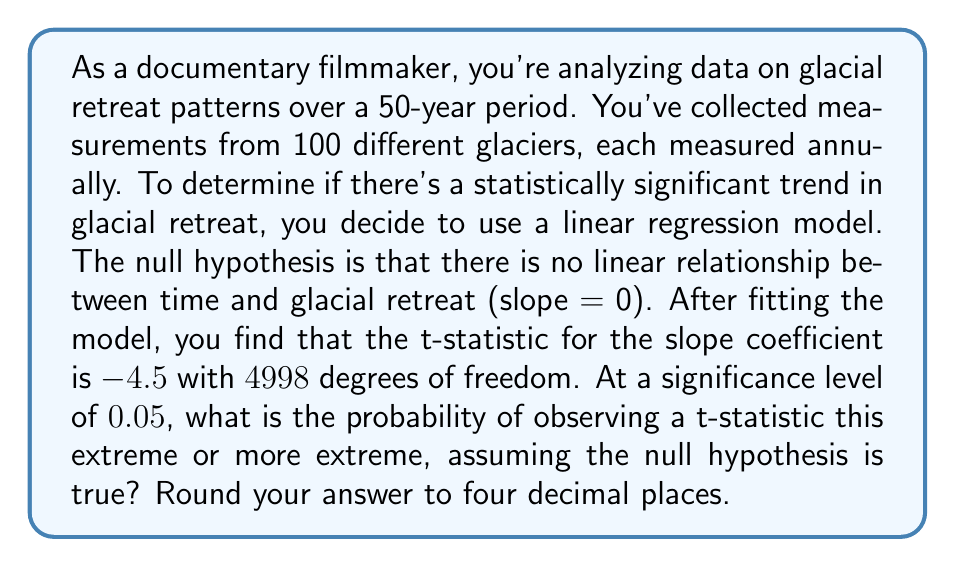Show me your answer to this math problem. To solve this problem, we'll follow these steps:

1) We're dealing with a two-tailed t-test, as we're interested in both positive and negative deviations from the null hypothesis.

2) The t-statistic is -4.5, but for a two-tailed test, we need to consider the absolute value: |-4.5| = 4.5.

3) We have 4998 degrees of freedom, which is large enough to approximate the t-distribution with a standard normal distribution.

4) We need to find P(|T| ≥ 4.5), where T follows a standard normal distribution.

5) This probability is equal to 2 * P(T ≥ 4.5), due to the symmetry of the standard normal distribution.

6) Using a standard normal table or calculator, we can find:
   P(T ≥ 4.5) ≈ 3.3977 × 10^-6

7) Therefore, P(|T| ≥ 4.5) ≈ 2 * 3.3977 × 10^-6 = 6.7954 × 10^-6

8) Rounding to four decimal places: 0.0000

The probability is extremely small, much smaller than the significance level of 0.05. This suggests strong evidence against the null hypothesis, indicating a statistically significant trend in glacial retreat over time.
Answer: 0.0000 